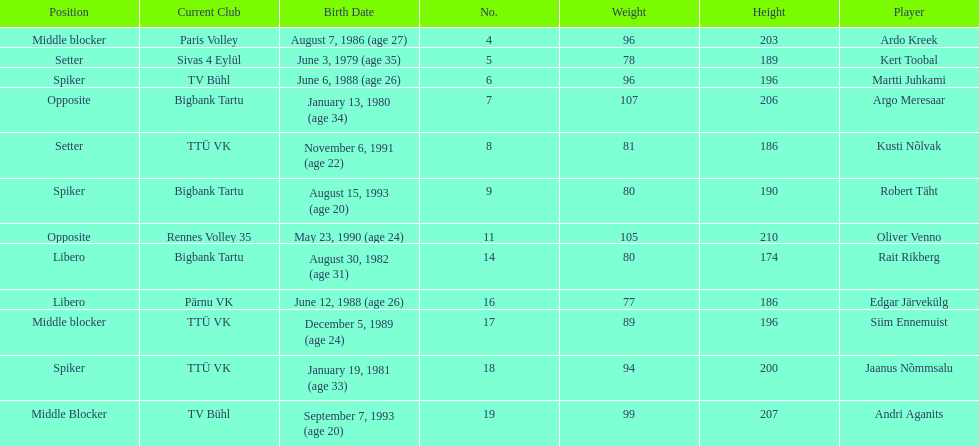Kert toobal is the oldest who is the next oldest player listed? Argo Meresaar. 